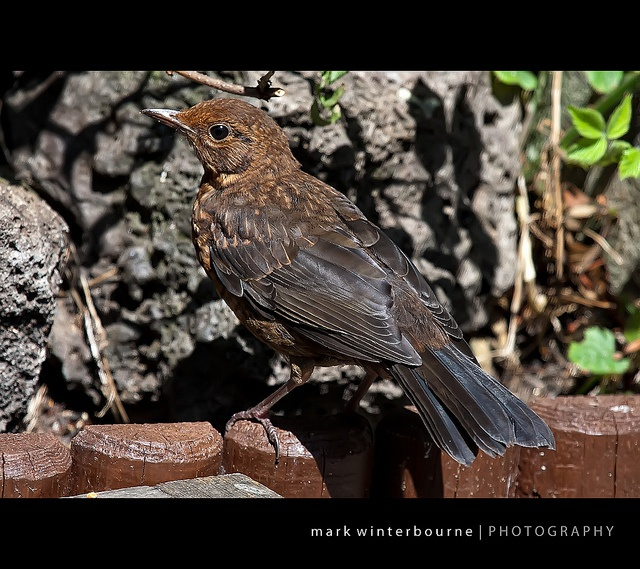Describe the objects in this image and their specific colors. I can see a bird in black, gray, and maroon tones in this image. 